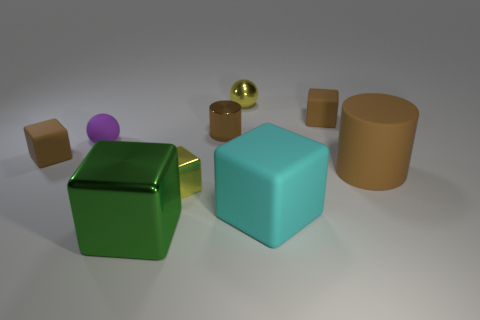There is a large thing that is the same color as the small cylinder; what is its shape?
Keep it short and to the point. Cylinder. Is there another large metal object of the same shape as the green metallic object?
Provide a short and direct response. No. Are there fewer yellow metal things on the left side of the purple thing than brown metallic objects that are left of the cyan thing?
Your answer should be very brief. Yes. The matte sphere is what color?
Offer a very short reply. Purple. Is there a big brown thing that is on the left side of the sphere to the right of the green shiny thing?
Provide a short and direct response. No. How many brown cylinders are the same size as the cyan matte block?
Your answer should be very brief. 1. What number of yellow metal spheres are on the right side of the tiny brown matte thing on the right side of the green block that is on the left side of the tiny shiny block?
Offer a terse response. 0. How many brown things are right of the green metallic cube and behind the large brown rubber object?
Provide a succinct answer. 2. Is there anything else of the same color as the small metallic cylinder?
Provide a short and direct response. Yes. What number of matte things are either big cubes or small brown blocks?
Ensure brevity in your answer.  3. 